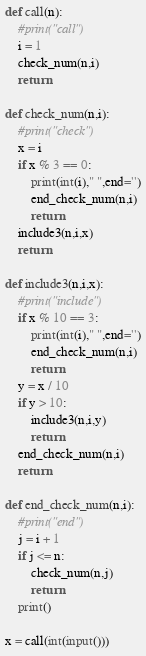Convert code to text. <code><loc_0><loc_0><loc_500><loc_500><_Python_>def call(n):
    #print("call")
    i = 1
    check_num(n,i)
    return

def check_num(n,i):
    #print("check")
    x = i
    if x % 3 == 0:
        print(int(i)," ",end='')
        end_check_num(n,i)
        return
    include3(n,i,x)
    return

def include3(n,i,x):
    #print("include")
    if x % 10 == 3:
        print(int(i)," ",end='')
        end_check_num(n,i)
        return
    y = x / 10
    if y > 10:
        include3(n,i,y)
        return
    end_check_num(n,i)
    return

def end_check_num(n,i):
    #print("end")
    j = i + 1
    if j <= n:
        check_num(n,j)
        return
    print()

x = call(int(input()))
</code> 